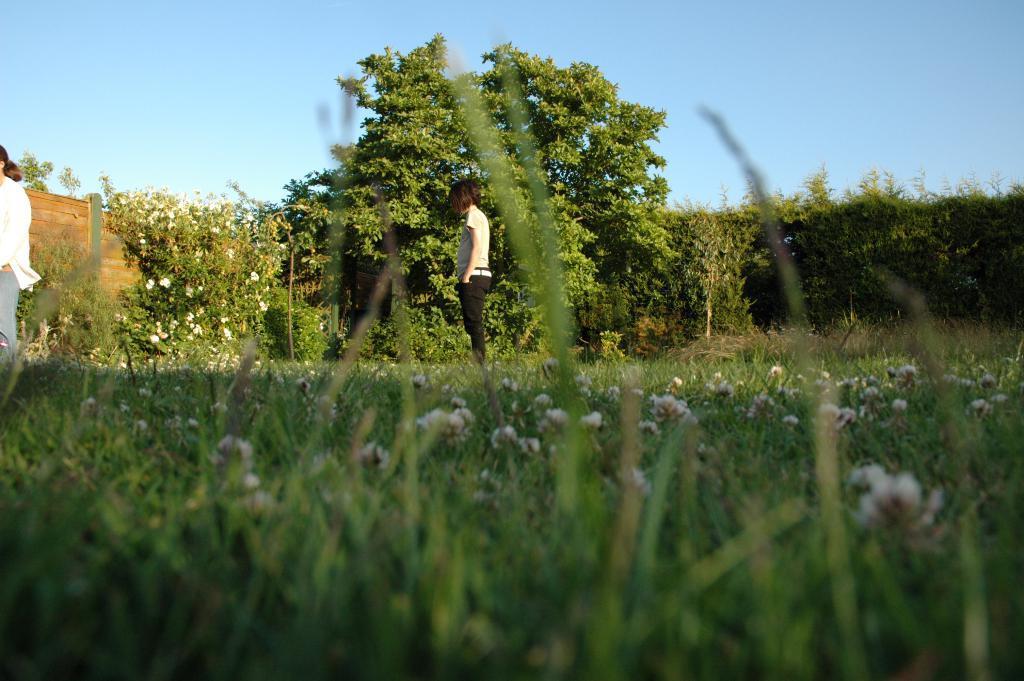Please provide a concise description of this image. In the center of the image we can see a person is standing. On the left side of the image we can see a lady is standing. In the background of the image we can see the wall, trees, plants and flowers. At the bottom of the image we can see the grass and flowers. At the top of the image we can see the sky. 